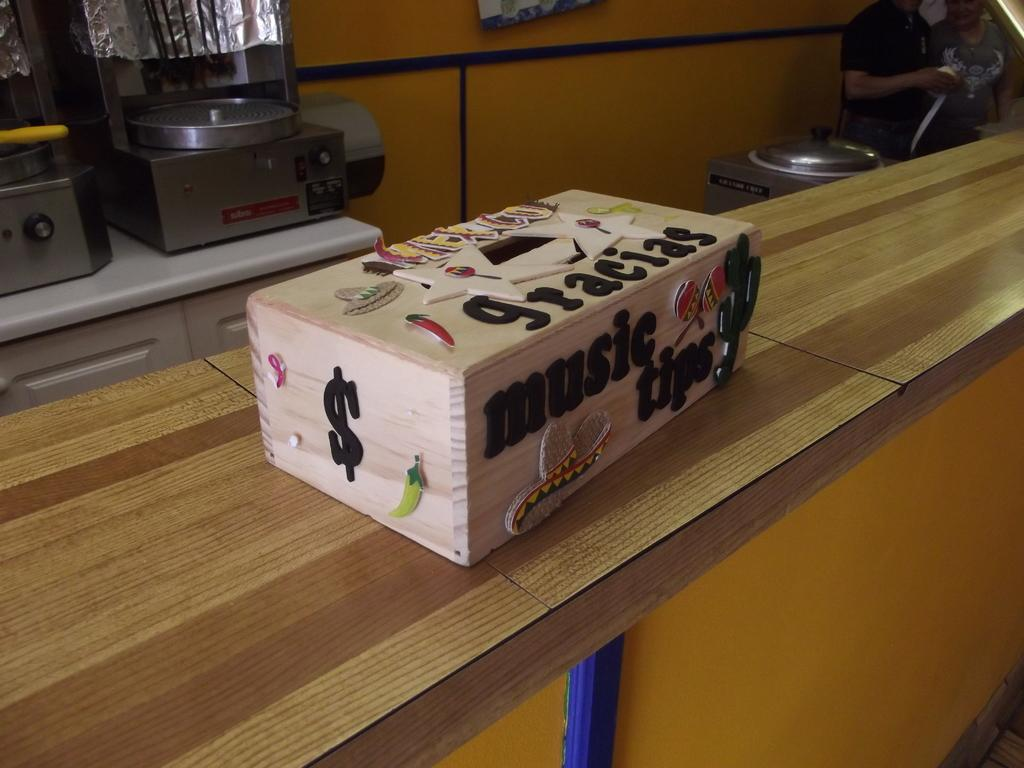<image>
Write a terse but informative summary of the picture. A wooden box has words music tips on the side of it. 